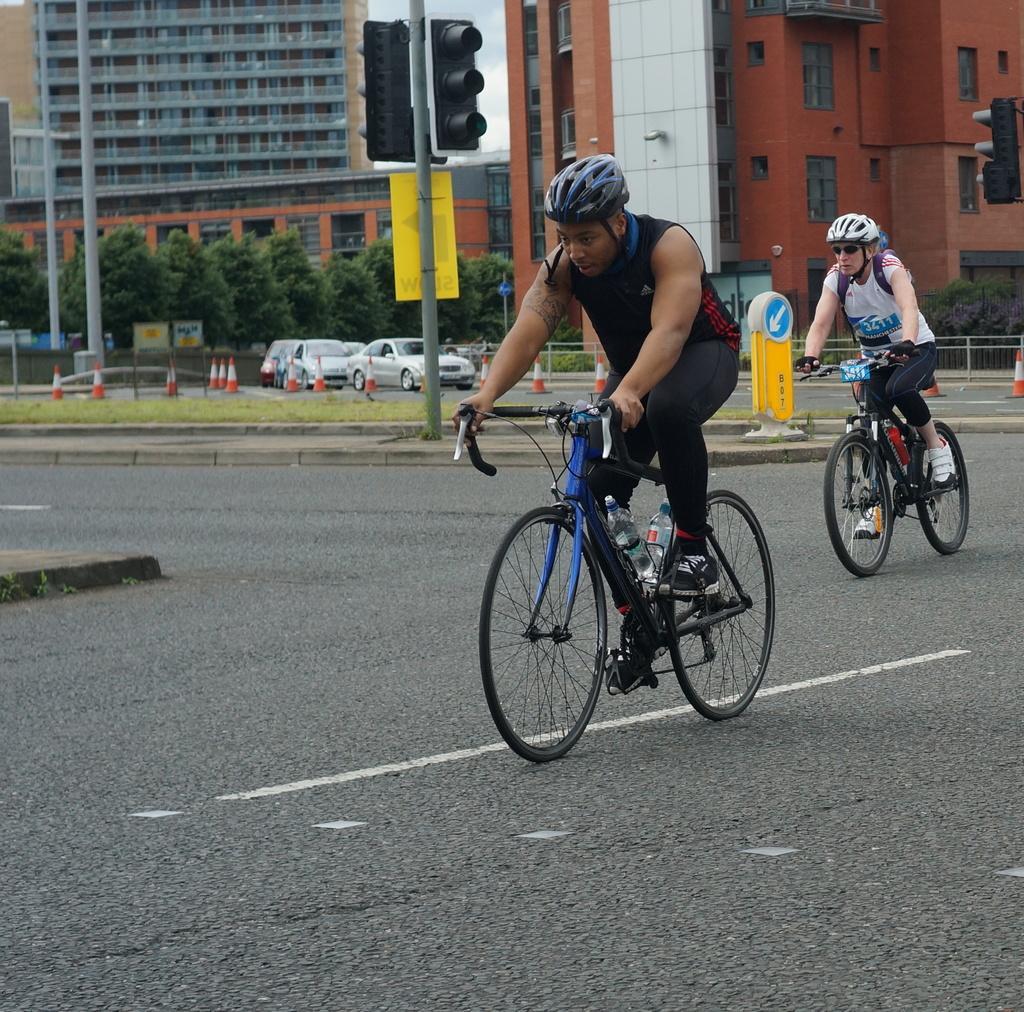In one or two sentences, can you explain what this image depicts? In this picture we can see two people riding bicycles on the road, beside this road we can see a footpath, traffic signals, sign boards, traffic cones, fence and name boards. In the background we can see buildings, trees, sky. 